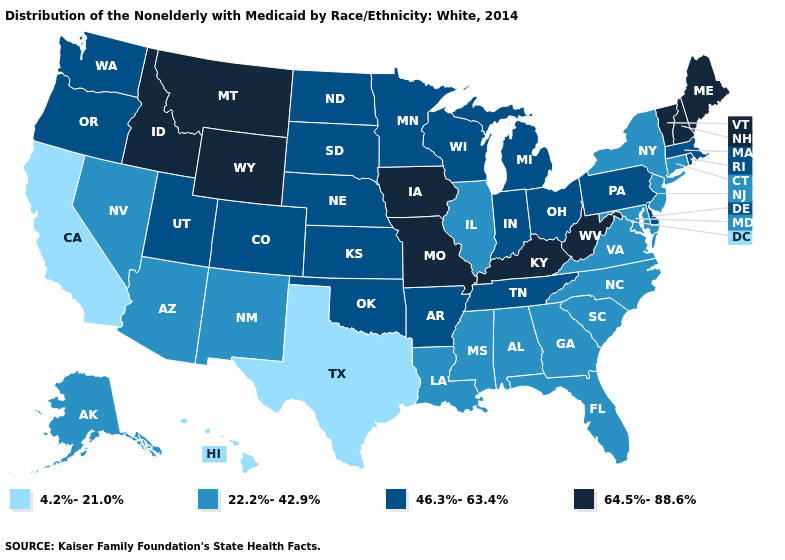Does Texas have the same value as Pennsylvania?
Be succinct. No. Is the legend a continuous bar?
Give a very brief answer. No. Does South Dakota have the same value as Iowa?
Answer briefly. No. Which states hav the highest value in the West?
Be succinct. Idaho, Montana, Wyoming. Among the states that border West Virginia , which have the lowest value?
Keep it brief. Maryland, Virginia. Name the states that have a value in the range 64.5%-88.6%?
Concise answer only. Idaho, Iowa, Kentucky, Maine, Missouri, Montana, New Hampshire, Vermont, West Virginia, Wyoming. Does the first symbol in the legend represent the smallest category?
Quick response, please. Yes. Does Rhode Island have the highest value in the USA?
Short answer required. No. What is the lowest value in the USA?
Give a very brief answer. 4.2%-21.0%. Which states hav the highest value in the West?
Give a very brief answer. Idaho, Montana, Wyoming. Among the states that border California , which have the highest value?
Short answer required. Oregon. Does the map have missing data?
Write a very short answer. No. What is the value of South Carolina?
Concise answer only. 22.2%-42.9%. What is the value of Tennessee?
Write a very short answer. 46.3%-63.4%. 